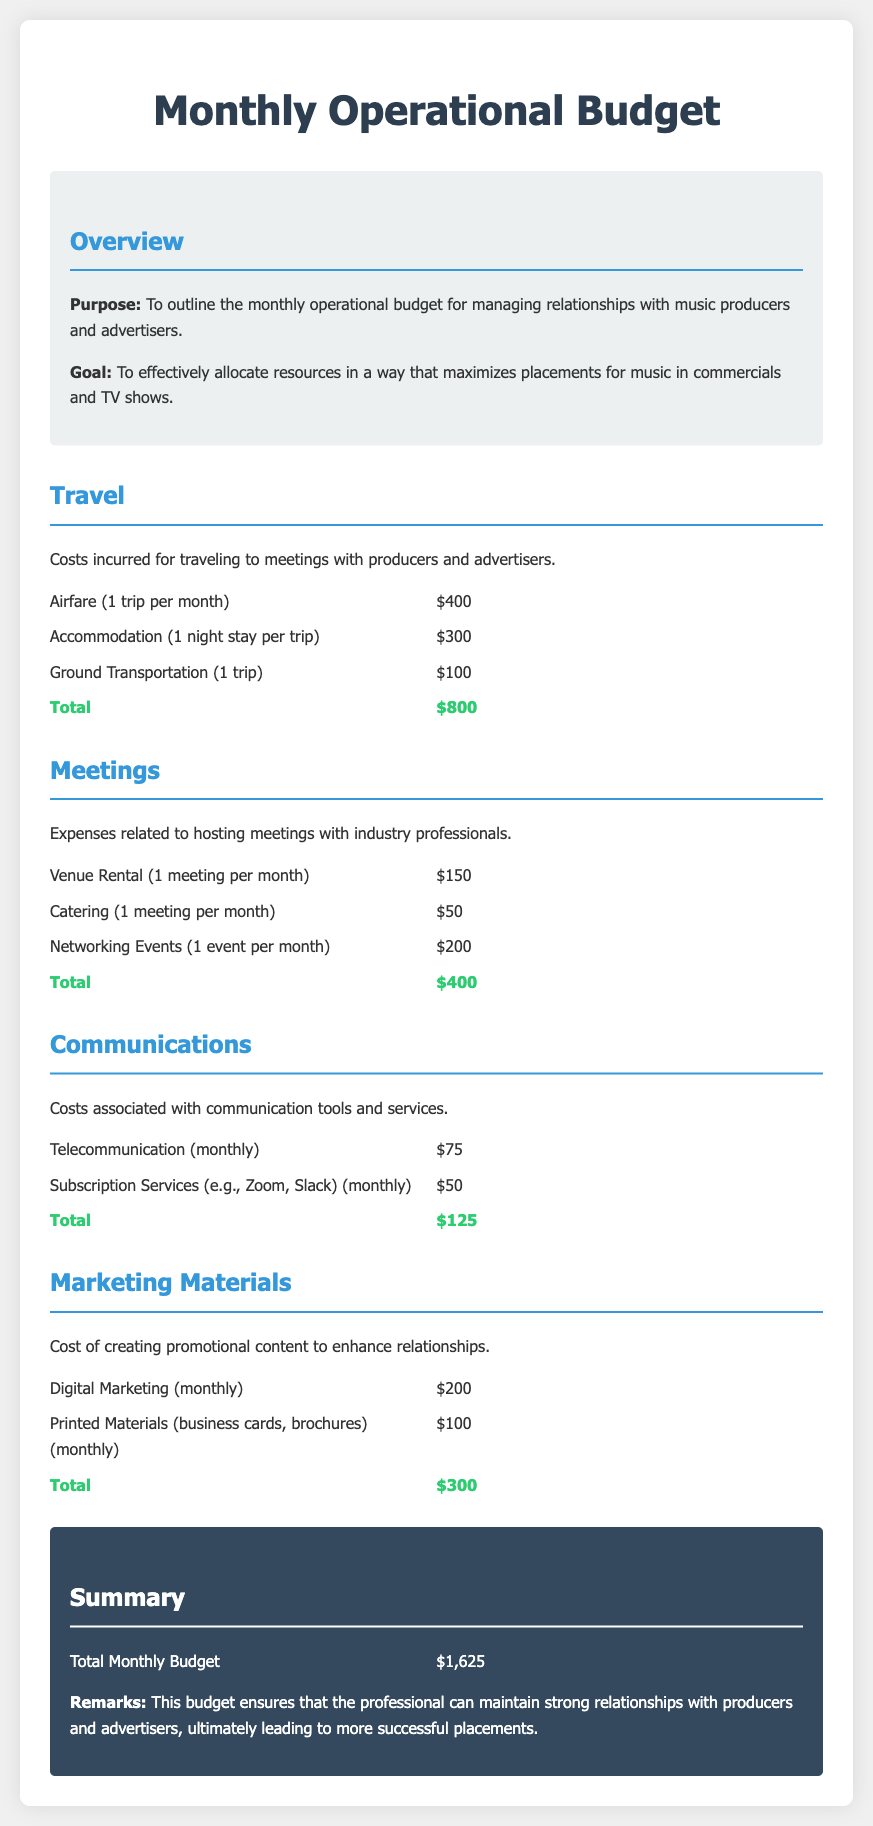What is the total monthly budget? The total monthly budget is the sum of all expense categories detailed in the document, which is $800 + $400 + $125 + $300 = $1,625.
Answer: $1,625 How much is spent on travel? The travel section details airfare, accommodation, and ground transportation, summing to $800.
Answer: $800 What is the cost of catering for meetings? Catering is listed as a monthly expense of $50 in the meetings section.
Answer: $50 How many networking events are planned per month? The document mentions 1 networking event per month in the meetings category.
Answer: 1 What is the total expense for communications? The total for communications, including telecommunication and subscription services, adds up to $125.
Answer: $125 What category incurs the highest expense? Travel is identified as the highest expense category, totaling $800.
Answer: Travel How much is invested in digital marketing monthly? The digital marketing expense listed in the marketing materials section is $200 monthly.
Answer: $200 How much does the venue rental cost for meetings? Venue rental is specified as costing $150 per meeting.
Answer: $150 What is the combined total for marketing materials? The marketing materials expenses total $300 when both digital and printed materials are added together.
Answer: $300 What is the purpose of the budget document? The document states the purpose is to outline the monthly operational budget for managing relationships with music producers and advertisers.
Answer: Outline budget 